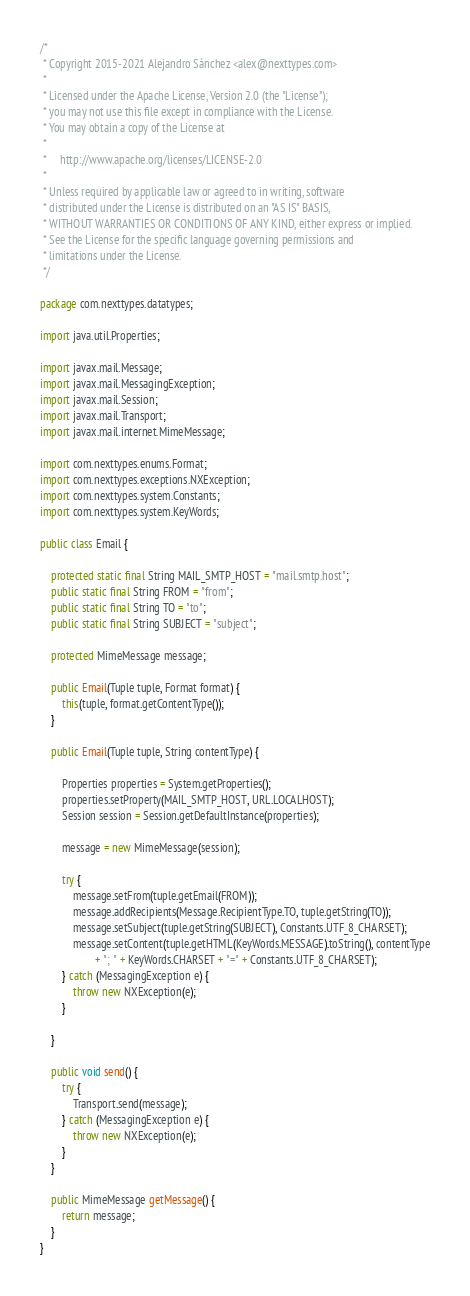Convert code to text. <code><loc_0><loc_0><loc_500><loc_500><_Java_>/*
 * Copyright 2015-2021 Alejandro Sánchez <alex@nexttypes.com>
 *
 * Licensed under the Apache License, Version 2.0 (the "License");
 * you may not use this file except in compliance with the License.
 * You may obtain a copy of the License at
 *
 *     http://www.apache.org/licenses/LICENSE-2.0
 *
 * Unless required by applicable law or agreed to in writing, software
 * distributed under the License is distributed on an "AS IS" BASIS,
 * WITHOUT WARRANTIES OR CONDITIONS OF ANY KIND, either express or implied.
 * See the License for the specific language governing permissions and
 * limitations under the License.
 */

package com.nexttypes.datatypes;

import java.util.Properties;

import javax.mail.Message;
import javax.mail.MessagingException;
import javax.mail.Session;
import javax.mail.Transport;
import javax.mail.internet.MimeMessage;

import com.nexttypes.enums.Format;
import com.nexttypes.exceptions.NXException;
import com.nexttypes.system.Constants;
import com.nexttypes.system.KeyWords;

public class Email {
	
	protected static final String MAIL_SMTP_HOST = "mail.smtp.host";
	public static final String FROM = "from";
	public static final String TO = "to";
	public static final String SUBJECT = "subject";
	
	protected MimeMessage message;
	
	public Email(Tuple tuple, Format format) {
		this(tuple, format.getContentType());
	}
	
	public Email(Tuple tuple, String contentType) {
		
		Properties properties = System.getProperties();
		properties.setProperty(MAIL_SMTP_HOST, URL.LOCALHOST);
		Session session = Session.getDefaultInstance(properties);

		message = new MimeMessage(session);
		
		try {
			message.setFrom(tuple.getEmail(FROM));
			message.addRecipients(Message.RecipientType.TO, tuple.getString(TO));
			message.setSubject(tuple.getString(SUBJECT), Constants.UTF_8_CHARSET);
			message.setContent(tuple.getHTML(KeyWords.MESSAGE).toString(), contentType
					+ "; " + KeyWords.CHARSET + "=" + Constants.UTF_8_CHARSET);	
		} catch (MessagingException e) {
			throw new NXException(e);
		}
				
	}
	
	public void send() {
		try {
			Transport.send(message);
		} catch (MessagingException e) {
			throw new NXException(e);
		}
	}
	
	public MimeMessage getMessage() {
		return message;
	}
}
</code> 